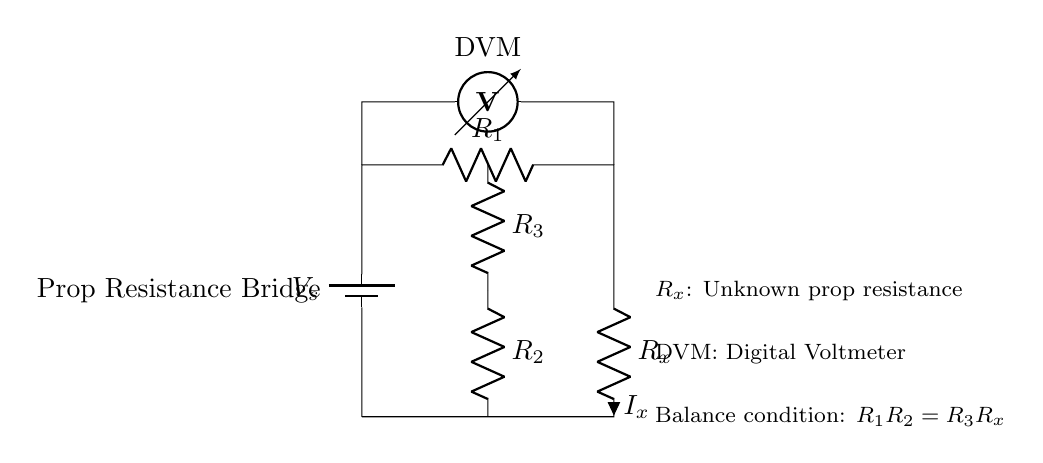What does R_x represent in this circuit? R_x represents the unknown prop resistance to be measured in the circuit. It is the variable component whose value we need to find through the balance condition of the bridge.
Answer: Unknown prop resistance What is the balance condition of the circuit? The balance condition states that the product of R_1 and R_2 must equal the product of R_3 and R_x, which is expressed in the equation R_1R_2 = R_3R_x. This relationship ensures that there is no current flowing through the meter when the bridge is balanced.
Answer: R_1R_2 = R_3R_x What type of circuit is shown? The circuit shown is a bridge circuit, specifically a prop resistance bridge used to measure unknown resistances accurately.
Answer: Bridge circuit What is the purpose of the DVM in this circuit? The DVM, or Digital Voltmeter, is used to measure the voltage across the circuit components. In this setup, it helps in identifying when the bridge is balanced by checking the voltage difference.
Answer: Measure voltage What are R_1 and R_2 in terms of the circuit? R_1 and R_2 are known resistances used in the bridge circuit for comparison with the unknown resistance R_x to achieve a balance condition. These components are essential for determining the value of the unknown resistance.
Answer: Known resistances How are the resistance values arranged in the circuit? The resistances R_1 and R_2 are in one leg of the bridge, while R_3 and R_x are in the other leg. This arrangement allows for the comparison of ratios, which is the foundation of the bridge circuit measurement principle.
Answer: In two legs of the bridge 